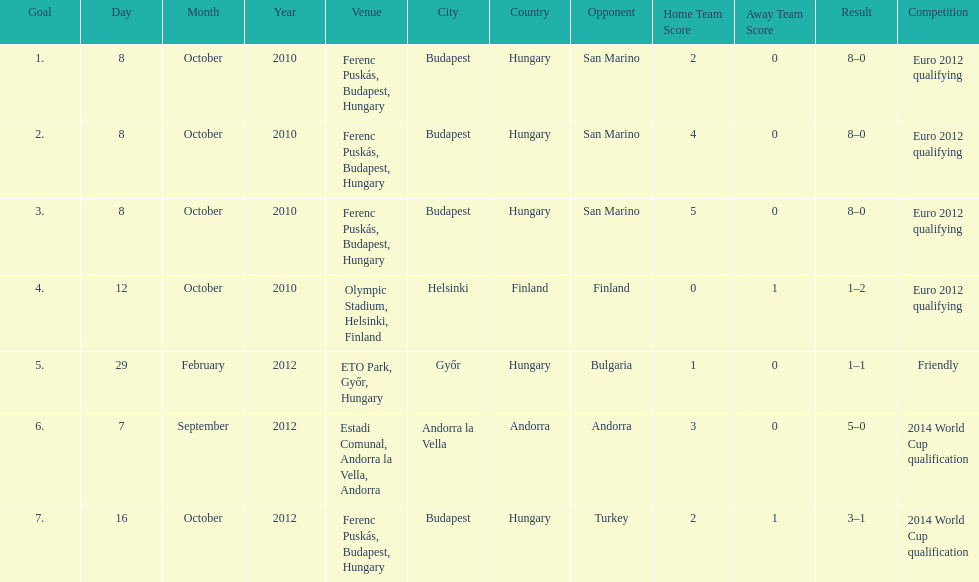I'm looking to parse the entire table for insights. Could you assist me with that? {'header': ['Goal', 'Day', 'Month', 'Year', 'Venue', 'City', 'Country', 'Opponent', 'Home Team Score', 'Away Team Score', 'Result', 'Competition'], 'rows': [['1.', '8', 'October', '2010', 'Ferenc Puskás, Budapest, Hungary', 'Budapest', 'Hungary', 'San Marino', '2', '0', '8–0', 'Euro 2012 qualifying'], ['2.', '8', 'October', '2010', 'Ferenc Puskás, Budapest, Hungary', 'Budapest', 'Hungary', 'San Marino', '4', '0', '8–0', 'Euro 2012 qualifying'], ['3.', '8', 'October', '2010', 'Ferenc Puskás, Budapest, Hungary', 'Budapest', 'Hungary', 'San Marino', '5', '0', '8–0', 'Euro 2012 qualifying'], ['4.', '12', 'October', '2010', 'Olympic Stadium, Helsinki, Finland', 'Helsinki', 'Finland', 'Finland', '0', '1', '1–2', 'Euro 2012 qualifying'], ['5.', '29', 'February', '2012', 'ETO Park, Győr, Hungary', 'Győr', 'Hungary', 'Bulgaria', '1', '0', '1–1', 'Friendly'], ['6.', '7', 'September', '2012', 'Estadi Comunal, Andorra la Vella, Andorra', 'Andorra la Vella', 'Andorra', 'Andorra', '3', '0', '5–0', '2014 World Cup qualification'], ['7.', '16', 'October', '2012', 'Ferenc Puskás, Budapest, Hungary', 'Budapest', 'Hungary', 'Turkey', '2', '1', '3–1', '2014 World Cup qualification']]} How many goals were scored at the euro 2012 qualifying competition? 12. 